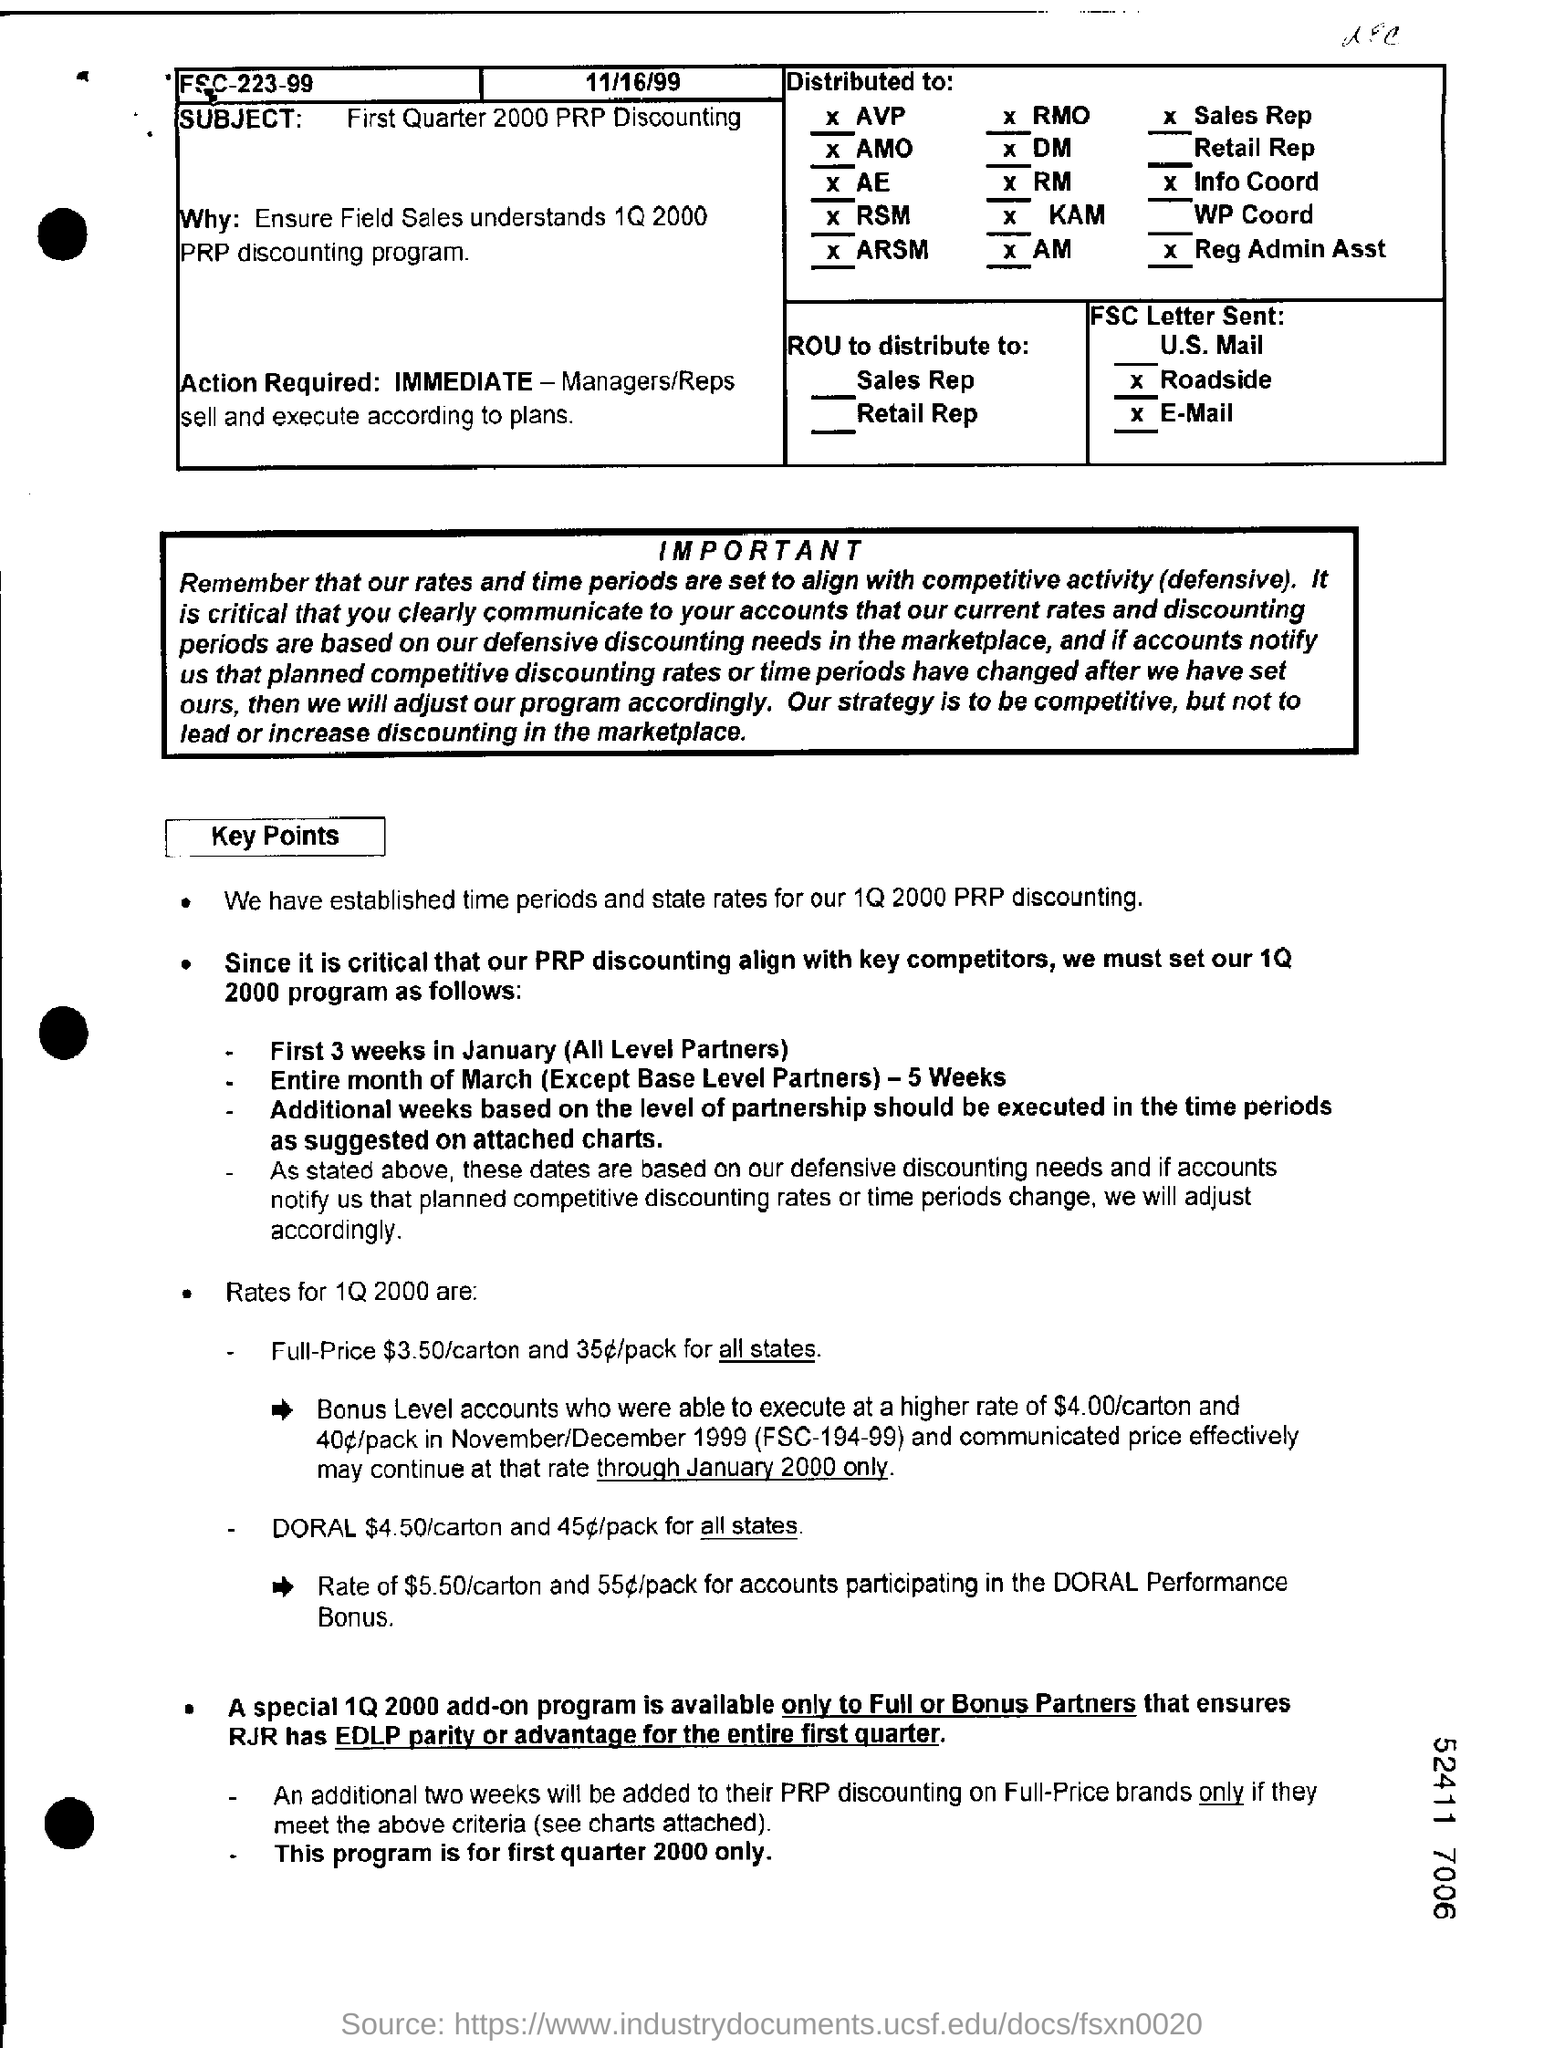What is the subject of the document?
Your answer should be compact. First quarter 2000 prp discounting. What is the action required?
Offer a very short reply. Immediate-managers/ reps sell and execute according to plans. For whom is a special 1Q 2000 add-on program available?
Give a very brief answer. Only to full or bonus partners. 